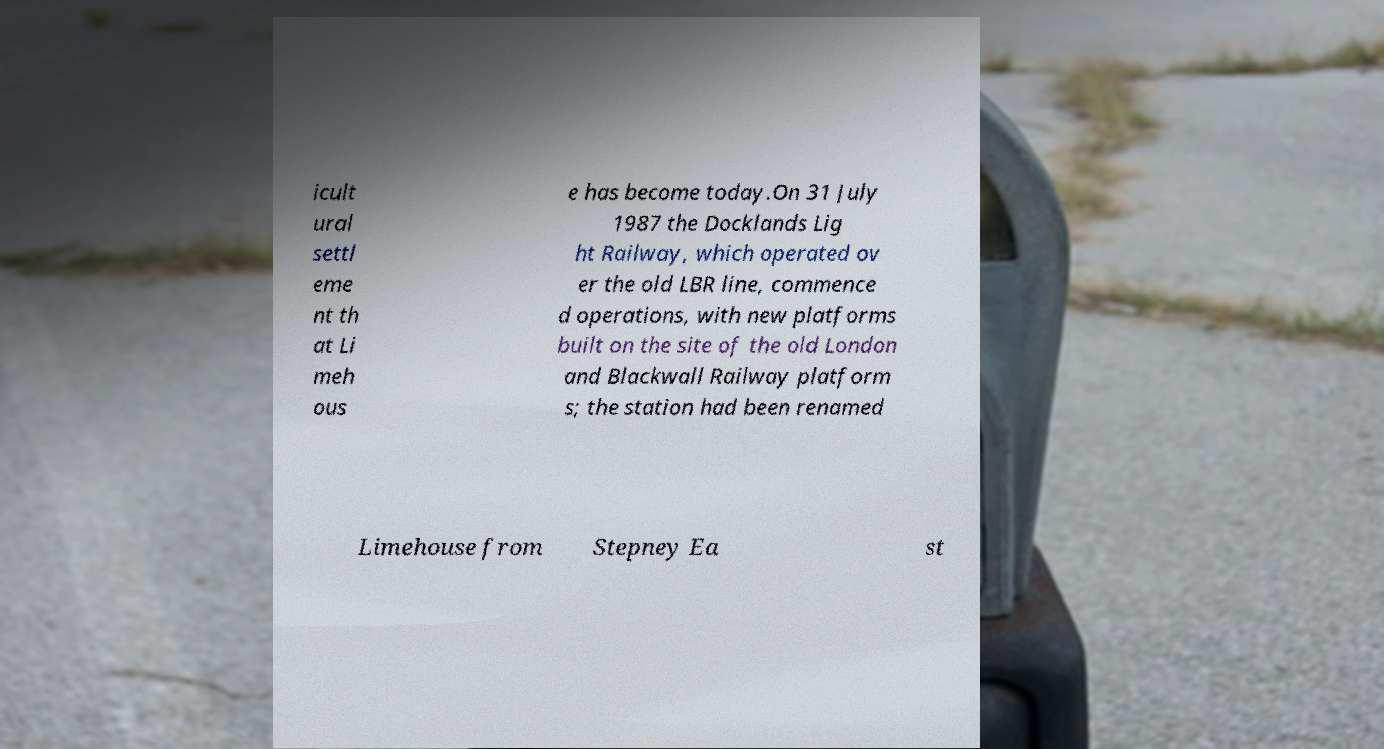Please read and relay the text visible in this image. What does it say? icult ural settl eme nt th at Li meh ous e has become today.On 31 July 1987 the Docklands Lig ht Railway, which operated ov er the old LBR line, commence d operations, with new platforms built on the site of the old London and Blackwall Railway platform s; the station had been renamed Limehouse from Stepney Ea st 